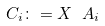<formula> <loc_0><loc_0><loc_500><loc_500>C _ { i } \colon = X \ A _ { i }</formula> 